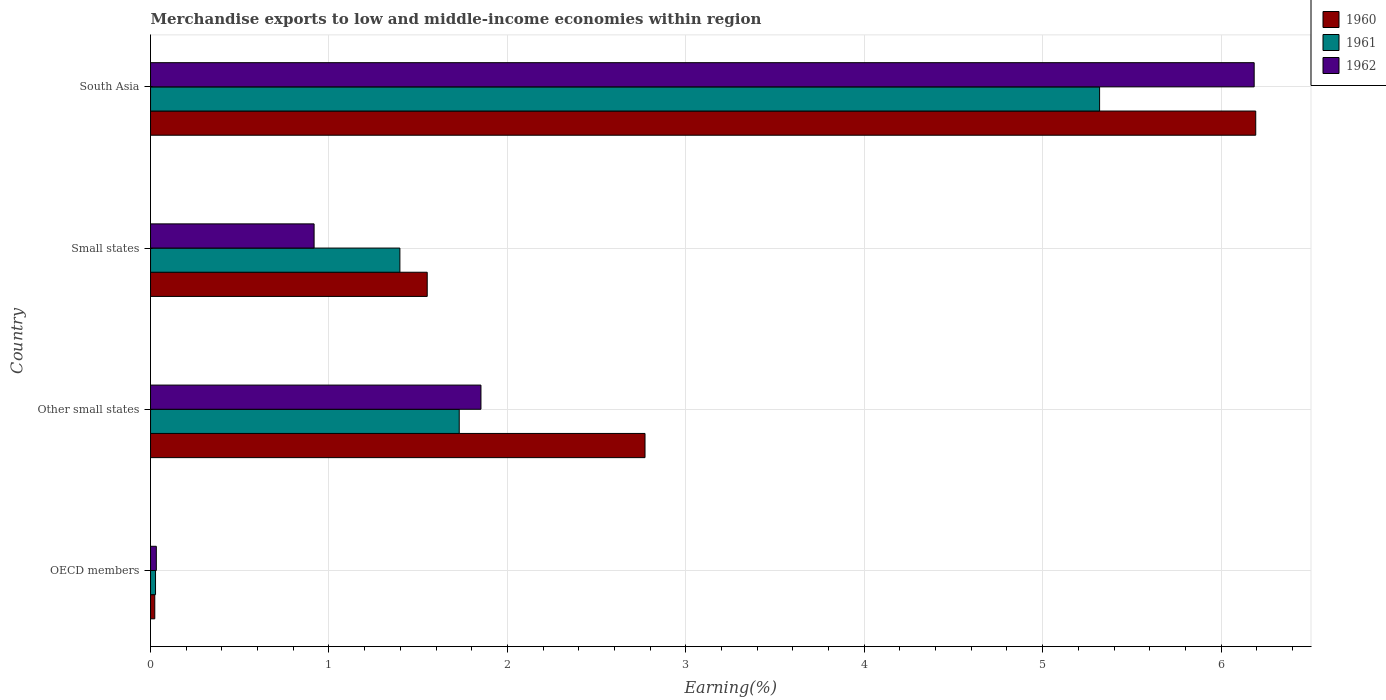How many different coloured bars are there?
Your response must be concise. 3. How many groups of bars are there?
Make the answer very short. 4. Are the number of bars per tick equal to the number of legend labels?
Your answer should be very brief. Yes. Are the number of bars on each tick of the Y-axis equal?
Give a very brief answer. Yes. What is the percentage of amount earned from merchandise exports in 1960 in OECD members?
Offer a very short reply. 0.02. Across all countries, what is the maximum percentage of amount earned from merchandise exports in 1962?
Your answer should be very brief. 6.19. Across all countries, what is the minimum percentage of amount earned from merchandise exports in 1962?
Your answer should be very brief. 0.03. In which country was the percentage of amount earned from merchandise exports in 1961 maximum?
Provide a succinct answer. South Asia. What is the total percentage of amount earned from merchandise exports in 1960 in the graph?
Offer a very short reply. 10.54. What is the difference between the percentage of amount earned from merchandise exports in 1960 in Other small states and that in South Asia?
Your answer should be compact. -3.42. What is the difference between the percentage of amount earned from merchandise exports in 1961 in Other small states and the percentage of amount earned from merchandise exports in 1960 in OECD members?
Offer a very short reply. 1.71. What is the average percentage of amount earned from merchandise exports in 1960 per country?
Make the answer very short. 2.64. What is the difference between the percentage of amount earned from merchandise exports in 1962 and percentage of amount earned from merchandise exports in 1961 in South Asia?
Make the answer very short. 0.87. In how many countries, is the percentage of amount earned from merchandise exports in 1960 greater than 3.6 %?
Offer a very short reply. 1. What is the ratio of the percentage of amount earned from merchandise exports in 1962 in OECD members to that in South Asia?
Keep it short and to the point. 0.01. Is the percentage of amount earned from merchandise exports in 1962 in Other small states less than that in South Asia?
Your answer should be compact. Yes. Is the difference between the percentage of amount earned from merchandise exports in 1962 in OECD members and South Asia greater than the difference between the percentage of amount earned from merchandise exports in 1961 in OECD members and South Asia?
Provide a succinct answer. No. What is the difference between the highest and the second highest percentage of amount earned from merchandise exports in 1960?
Your answer should be compact. 3.42. What is the difference between the highest and the lowest percentage of amount earned from merchandise exports in 1960?
Offer a very short reply. 6.17. What does the 1st bar from the top in Small states represents?
Provide a succinct answer. 1962. Is it the case that in every country, the sum of the percentage of amount earned from merchandise exports in 1960 and percentage of amount earned from merchandise exports in 1962 is greater than the percentage of amount earned from merchandise exports in 1961?
Provide a short and direct response. Yes. How many countries are there in the graph?
Ensure brevity in your answer.  4. Are the values on the major ticks of X-axis written in scientific E-notation?
Provide a short and direct response. No. Does the graph contain grids?
Your answer should be very brief. Yes. What is the title of the graph?
Your answer should be very brief. Merchandise exports to low and middle-income economies within region. Does "2014" appear as one of the legend labels in the graph?
Ensure brevity in your answer.  No. What is the label or title of the X-axis?
Provide a short and direct response. Earning(%). What is the Earning(%) in 1960 in OECD members?
Your answer should be very brief. 0.02. What is the Earning(%) of 1961 in OECD members?
Give a very brief answer. 0.03. What is the Earning(%) of 1962 in OECD members?
Make the answer very short. 0.03. What is the Earning(%) of 1960 in Other small states?
Offer a terse response. 2.77. What is the Earning(%) of 1961 in Other small states?
Your answer should be very brief. 1.73. What is the Earning(%) of 1962 in Other small states?
Offer a terse response. 1.85. What is the Earning(%) of 1960 in Small states?
Provide a succinct answer. 1.55. What is the Earning(%) of 1961 in Small states?
Make the answer very short. 1.4. What is the Earning(%) of 1962 in Small states?
Provide a succinct answer. 0.92. What is the Earning(%) of 1960 in South Asia?
Your answer should be very brief. 6.19. What is the Earning(%) of 1961 in South Asia?
Provide a short and direct response. 5.32. What is the Earning(%) in 1962 in South Asia?
Your response must be concise. 6.19. Across all countries, what is the maximum Earning(%) of 1960?
Your answer should be very brief. 6.19. Across all countries, what is the maximum Earning(%) of 1961?
Give a very brief answer. 5.32. Across all countries, what is the maximum Earning(%) of 1962?
Offer a very short reply. 6.19. Across all countries, what is the minimum Earning(%) of 1960?
Provide a succinct answer. 0.02. Across all countries, what is the minimum Earning(%) of 1961?
Offer a very short reply. 0.03. Across all countries, what is the minimum Earning(%) of 1962?
Keep it short and to the point. 0.03. What is the total Earning(%) in 1960 in the graph?
Offer a very short reply. 10.54. What is the total Earning(%) of 1961 in the graph?
Provide a short and direct response. 8.47. What is the total Earning(%) in 1962 in the graph?
Your answer should be very brief. 8.99. What is the difference between the Earning(%) in 1960 in OECD members and that in Other small states?
Make the answer very short. -2.75. What is the difference between the Earning(%) in 1961 in OECD members and that in Other small states?
Keep it short and to the point. -1.7. What is the difference between the Earning(%) of 1962 in OECD members and that in Other small states?
Give a very brief answer. -1.82. What is the difference between the Earning(%) of 1960 in OECD members and that in Small states?
Your response must be concise. -1.53. What is the difference between the Earning(%) in 1961 in OECD members and that in Small states?
Your response must be concise. -1.37. What is the difference between the Earning(%) of 1962 in OECD members and that in Small states?
Your answer should be very brief. -0.88. What is the difference between the Earning(%) in 1960 in OECD members and that in South Asia?
Your response must be concise. -6.17. What is the difference between the Earning(%) of 1961 in OECD members and that in South Asia?
Make the answer very short. -5.29. What is the difference between the Earning(%) in 1962 in OECD members and that in South Asia?
Make the answer very short. -6.15. What is the difference between the Earning(%) in 1960 in Other small states and that in Small states?
Your response must be concise. 1.22. What is the difference between the Earning(%) in 1961 in Other small states and that in Small states?
Keep it short and to the point. 0.33. What is the difference between the Earning(%) in 1962 in Other small states and that in Small states?
Provide a succinct answer. 0.94. What is the difference between the Earning(%) in 1960 in Other small states and that in South Asia?
Your answer should be compact. -3.42. What is the difference between the Earning(%) of 1961 in Other small states and that in South Asia?
Give a very brief answer. -3.59. What is the difference between the Earning(%) of 1962 in Other small states and that in South Asia?
Your response must be concise. -4.33. What is the difference between the Earning(%) of 1960 in Small states and that in South Asia?
Provide a short and direct response. -4.64. What is the difference between the Earning(%) in 1961 in Small states and that in South Asia?
Provide a short and direct response. -3.92. What is the difference between the Earning(%) of 1962 in Small states and that in South Asia?
Offer a very short reply. -5.27. What is the difference between the Earning(%) of 1960 in OECD members and the Earning(%) of 1961 in Other small states?
Your answer should be very brief. -1.71. What is the difference between the Earning(%) in 1960 in OECD members and the Earning(%) in 1962 in Other small states?
Your answer should be compact. -1.83. What is the difference between the Earning(%) in 1961 in OECD members and the Earning(%) in 1962 in Other small states?
Your response must be concise. -1.82. What is the difference between the Earning(%) of 1960 in OECD members and the Earning(%) of 1961 in Small states?
Keep it short and to the point. -1.37. What is the difference between the Earning(%) of 1960 in OECD members and the Earning(%) of 1962 in Small states?
Your answer should be compact. -0.89. What is the difference between the Earning(%) of 1961 in OECD members and the Earning(%) of 1962 in Small states?
Offer a very short reply. -0.89. What is the difference between the Earning(%) of 1960 in OECD members and the Earning(%) of 1961 in South Asia?
Offer a terse response. -5.3. What is the difference between the Earning(%) of 1960 in OECD members and the Earning(%) of 1962 in South Asia?
Offer a terse response. -6.16. What is the difference between the Earning(%) of 1961 in OECD members and the Earning(%) of 1962 in South Asia?
Ensure brevity in your answer.  -6.16. What is the difference between the Earning(%) in 1960 in Other small states and the Earning(%) in 1961 in Small states?
Keep it short and to the point. 1.37. What is the difference between the Earning(%) in 1960 in Other small states and the Earning(%) in 1962 in Small states?
Provide a short and direct response. 1.85. What is the difference between the Earning(%) of 1961 in Other small states and the Earning(%) of 1962 in Small states?
Provide a succinct answer. 0.81. What is the difference between the Earning(%) of 1960 in Other small states and the Earning(%) of 1961 in South Asia?
Ensure brevity in your answer.  -2.55. What is the difference between the Earning(%) in 1960 in Other small states and the Earning(%) in 1962 in South Asia?
Your response must be concise. -3.41. What is the difference between the Earning(%) of 1961 in Other small states and the Earning(%) of 1962 in South Asia?
Make the answer very short. -4.46. What is the difference between the Earning(%) of 1960 in Small states and the Earning(%) of 1961 in South Asia?
Offer a terse response. -3.77. What is the difference between the Earning(%) of 1960 in Small states and the Earning(%) of 1962 in South Asia?
Give a very brief answer. -4.63. What is the difference between the Earning(%) in 1961 in Small states and the Earning(%) in 1962 in South Asia?
Keep it short and to the point. -4.79. What is the average Earning(%) in 1960 per country?
Your answer should be very brief. 2.63. What is the average Earning(%) in 1961 per country?
Give a very brief answer. 2.12. What is the average Earning(%) in 1962 per country?
Ensure brevity in your answer.  2.25. What is the difference between the Earning(%) of 1960 and Earning(%) of 1961 in OECD members?
Provide a succinct answer. -0. What is the difference between the Earning(%) of 1960 and Earning(%) of 1962 in OECD members?
Offer a very short reply. -0.01. What is the difference between the Earning(%) in 1961 and Earning(%) in 1962 in OECD members?
Provide a succinct answer. -0. What is the difference between the Earning(%) in 1960 and Earning(%) in 1961 in Other small states?
Offer a terse response. 1.04. What is the difference between the Earning(%) of 1960 and Earning(%) of 1962 in Other small states?
Offer a very short reply. 0.92. What is the difference between the Earning(%) of 1961 and Earning(%) of 1962 in Other small states?
Provide a succinct answer. -0.12. What is the difference between the Earning(%) in 1960 and Earning(%) in 1961 in Small states?
Your response must be concise. 0.15. What is the difference between the Earning(%) in 1960 and Earning(%) in 1962 in Small states?
Give a very brief answer. 0.63. What is the difference between the Earning(%) in 1961 and Earning(%) in 1962 in Small states?
Offer a terse response. 0.48. What is the difference between the Earning(%) in 1960 and Earning(%) in 1961 in South Asia?
Provide a succinct answer. 0.88. What is the difference between the Earning(%) of 1960 and Earning(%) of 1962 in South Asia?
Offer a terse response. 0.01. What is the difference between the Earning(%) in 1961 and Earning(%) in 1962 in South Asia?
Provide a short and direct response. -0.87. What is the ratio of the Earning(%) of 1960 in OECD members to that in Other small states?
Ensure brevity in your answer.  0.01. What is the ratio of the Earning(%) in 1961 in OECD members to that in Other small states?
Your answer should be very brief. 0.02. What is the ratio of the Earning(%) of 1962 in OECD members to that in Other small states?
Give a very brief answer. 0.02. What is the ratio of the Earning(%) of 1960 in OECD members to that in Small states?
Your answer should be very brief. 0.02. What is the ratio of the Earning(%) of 1962 in OECD members to that in Small states?
Give a very brief answer. 0.04. What is the ratio of the Earning(%) of 1960 in OECD members to that in South Asia?
Keep it short and to the point. 0. What is the ratio of the Earning(%) of 1961 in OECD members to that in South Asia?
Keep it short and to the point. 0.01. What is the ratio of the Earning(%) in 1962 in OECD members to that in South Asia?
Your response must be concise. 0.01. What is the ratio of the Earning(%) of 1960 in Other small states to that in Small states?
Offer a terse response. 1.79. What is the ratio of the Earning(%) in 1961 in Other small states to that in Small states?
Make the answer very short. 1.24. What is the ratio of the Earning(%) in 1962 in Other small states to that in Small states?
Provide a short and direct response. 2.02. What is the ratio of the Earning(%) in 1960 in Other small states to that in South Asia?
Offer a very short reply. 0.45. What is the ratio of the Earning(%) of 1961 in Other small states to that in South Asia?
Make the answer very short. 0.33. What is the ratio of the Earning(%) of 1962 in Other small states to that in South Asia?
Your answer should be very brief. 0.3. What is the ratio of the Earning(%) in 1960 in Small states to that in South Asia?
Give a very brief answer. 0.25. What is the ratio of the Earning(%) in 1961 in Small states to that in South Asia?
Offer a terse response. 0.26. What is the ratio of the Earning(%) in 1962 in Small states to that in South Asia?
Offer a terse response. 0.15. What is the difference between the highest and the second highest Earning(%) of 1960?
Offer a terse response. 3.42. What is the difference between the highest and the second highest Earning(%) of 1961?
Your answer should be compact. 3.59. What is the difference between the highest and the second highest Earning(%) in 1962?
Make the answer very short. 4.33. What is the difference between the highest and the lowest Earning(%) of 1960?
Provide a succinct answer. 6.17. What is the difference between the highest and the lowest Earning(%) in 1961?
Ensure brevity in your answer.  5.29. What is the difference between the highest and the lowest Earning(%) of 1962?
Provide a short and direct response. 6.15. 